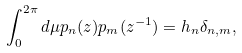<formula> <loc_0><loc_0><loc_500><loc_500>\int _ { 0 } ^ { 2 \pi } d \mu p _ { n } ( z ) p _ { m } ( z ^ { - 1 } ) = h _ { n } \delta _ { n , m } ,</formula> 